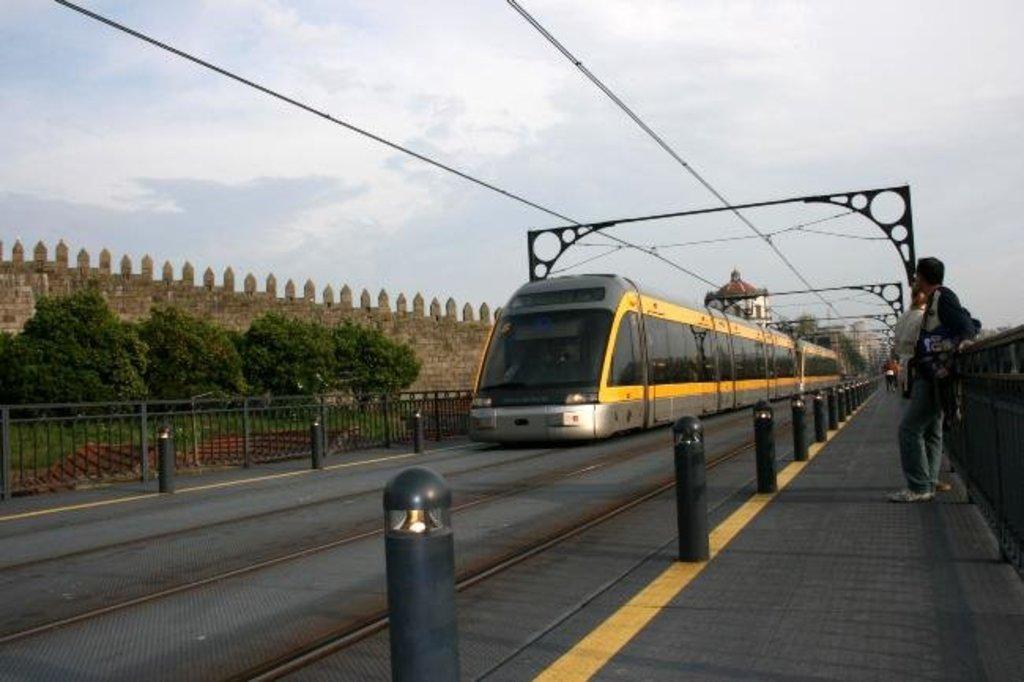In one or two sentences, can you explain what this image depicts? In this image we can see an electric train on the track. Right side of the image, platform is there and persons are standing on the platform. Left side of the image black color fencing, trees and boundary wall is there. At the top of the image sky is covered with clouds. 